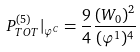Convert formula to latex. <formula><loc_0><loc_0><loc_500><loc_500>P ^ { ( 5 ) } _ { T O T } | _ { \varphi ^ { C } } = \frac { 9 } { 4 } \frac { ( W _ { 0 } ) ^ { 2 } } { ( \varphi ^ { 1 } ) ^ { 4 } }</formula> 